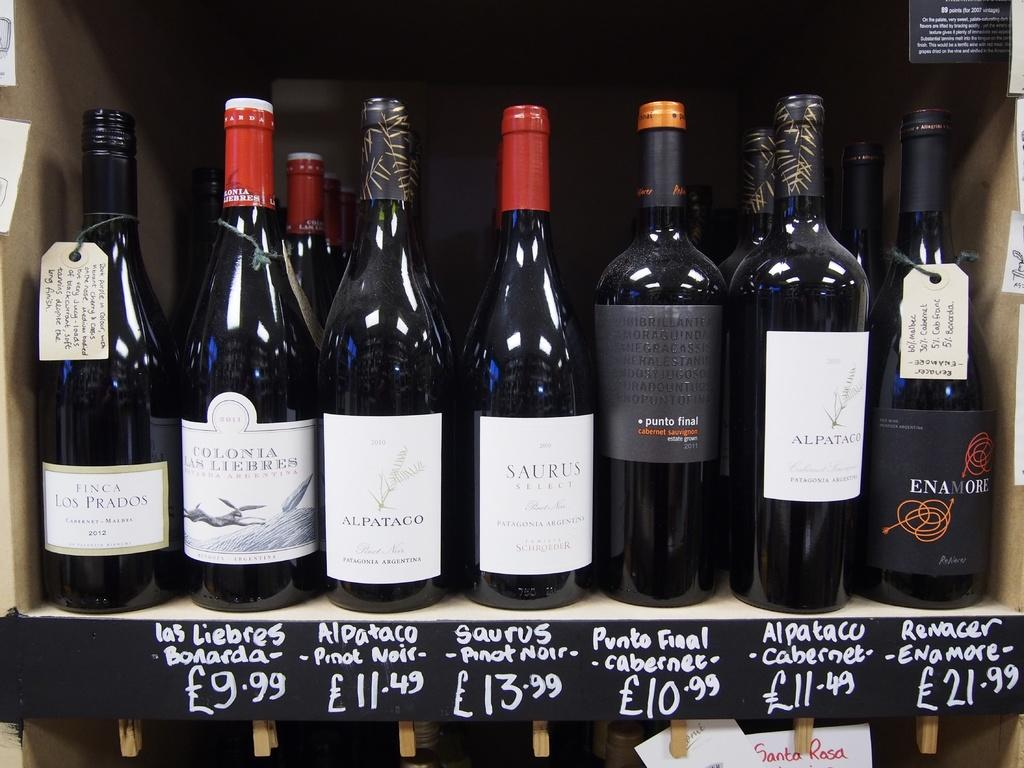What is the main subject of the image? The main subject of the image is many bottles. How are the bottles arranged in the image? The bottles are kept one over the other in a box. What is the purpose of the bottles in the image? The bottles are for sale. What type of produce can be seen growing in the image? There is no produce visible in the image; it only shows many bottles arranged in a box for sale. 